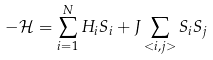Convert formula to latex. <formula><loc_0><loc_0><loc_500><loc_500>- \mathcal { H } = \sum _ { i = 1 } ^ { N } H _ { i } S _ { i } + J \sum _ { < i , j > } S _ { i } S _ { j }</formula> 